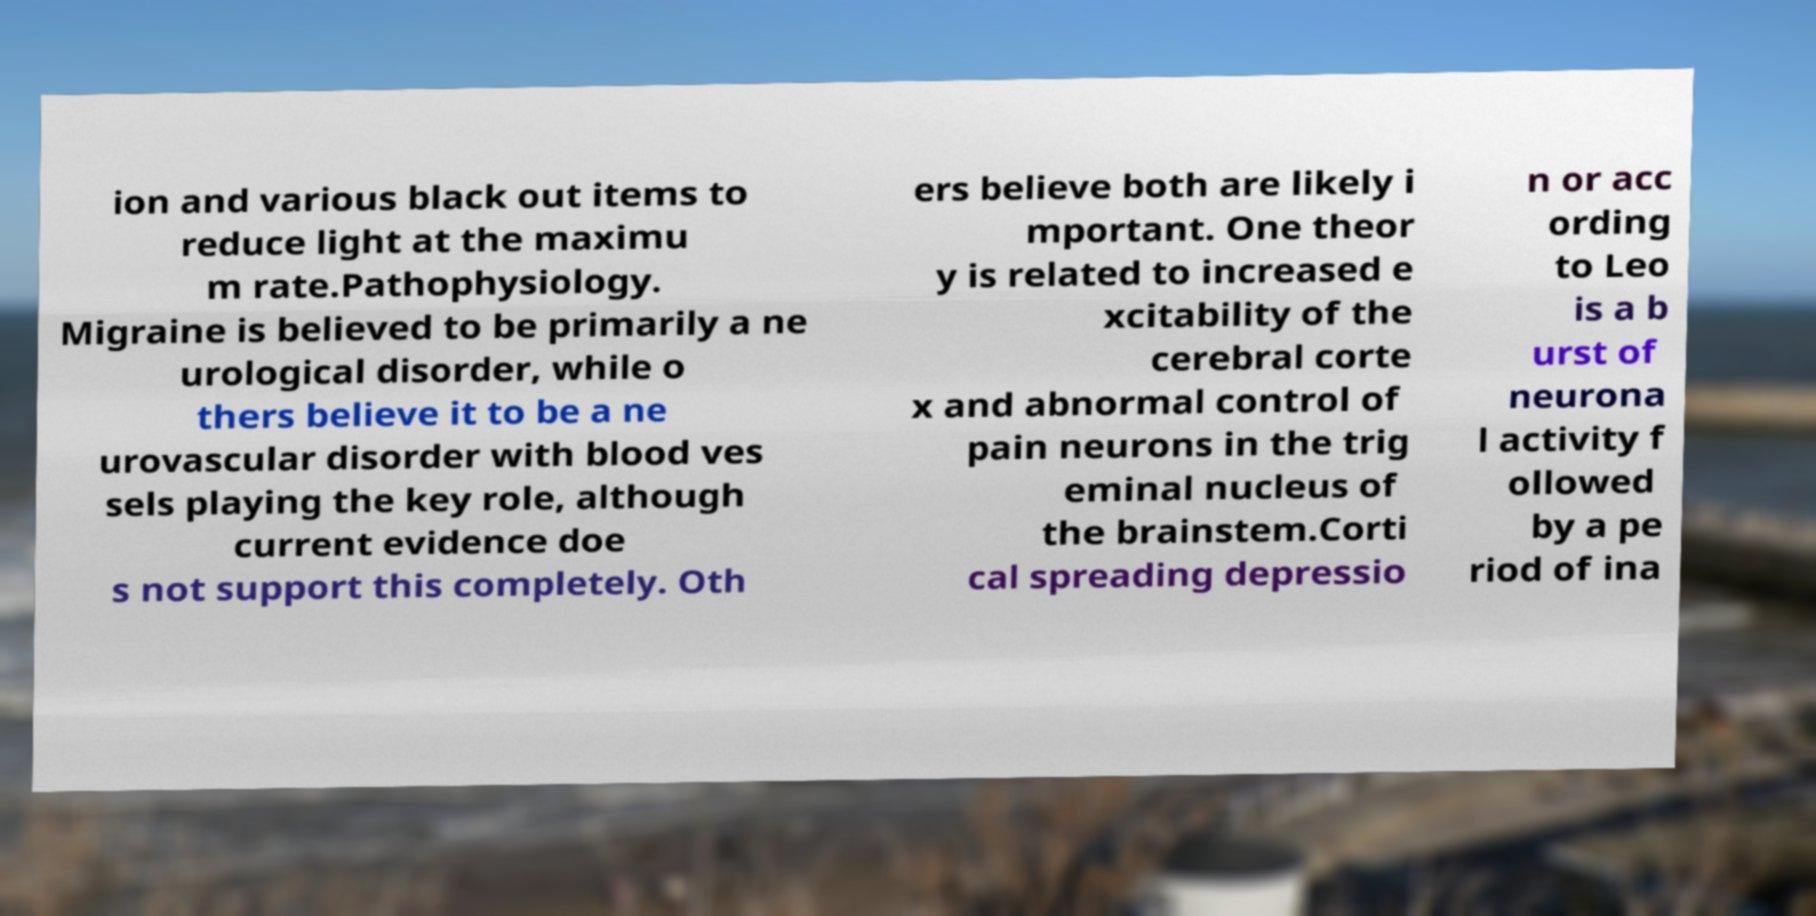For documentation purposes, I need the text within this image transcribed. Could you provide that? ion and various black out items to reduce light at the maximu m rate.Pathophysiology. Migraine is believed to be primarily a ne urological disorder, while o thers believe it to be a ne urovascular disorder with blood ves sels playing the key role, although current evidence doe s not support this completely. Oth ers believe both are likely i mportant. One theor y is related to increased e xcitability of the cerebral corte x and abnormal control of pain neurons in the trig eminal nucleus of the brainstem.Corti cal spreading depressio n or acc ording to Leo is a b urst of neurona l activity f ollowed by a pe riod of ina 